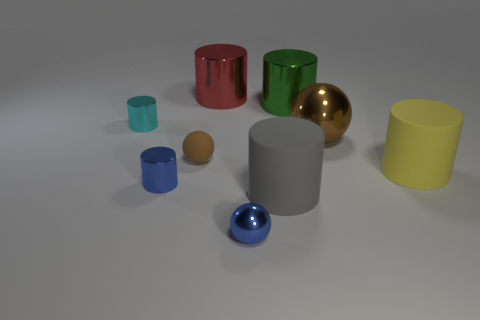Subtract all tiny blue cylinders. How many cylinders are left? 5 Subtract all blue cylinders. How many cylinders are left? 5 Subtract 2 cylinders. How many cylinders are left? 4 Subtract all brown cylinders. Subtract all red blocks. How many cylinders are left? 6 Add 1 small purple metal blocks. How many objects exist? 10 Subtract all cylinders. How many objects are left? 3 Add 9 gray things. How many gray things are left? 10 Add 3 big yellow objects. How many big yellow objects exist? 4 Subtract 0 cyan blocks. How many objects are left? 9 Subtract all large matte things. Subtract all big green cylinders. How many objects are left? 6 